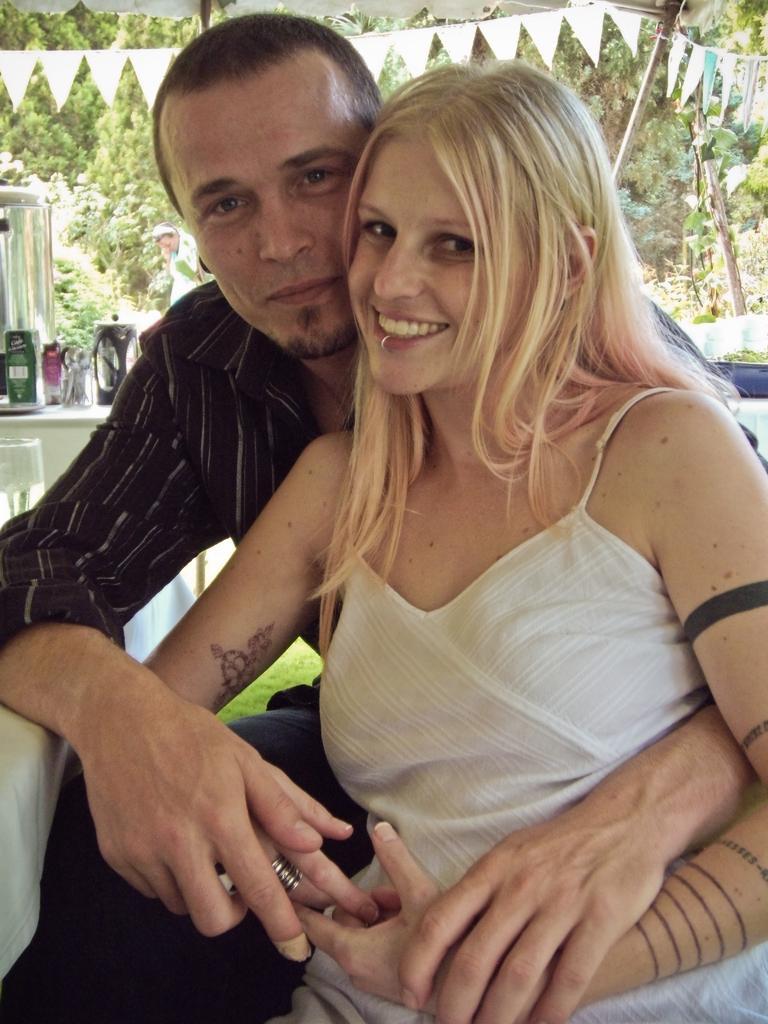How would you summarize this image in a sentence or two? In this picture I can observe a couple. Both of them are smiling. In the background I can observe trees. 